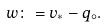Convert formula to latex. <formula><loc_0><loc_0><loc_500><loc_500>w \colon = v _ { \ast } - q _ { \circ } .</formula> 